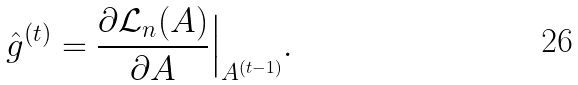Convert formula to latex. <formula><loc_0><loc_0><loc_500><loc_500>\hat { g } ^ { ( t ) } = \frac { \partial \mathcal { L } _ { n } ( A ) } { \partial A } \Big | _ { A ^ { ( t - 1 ) } } .</formula> 